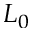Convert formula to latex. <formula><loc_0><loc_0><loc_500><loc_500>L _ { 0 }</formula> 